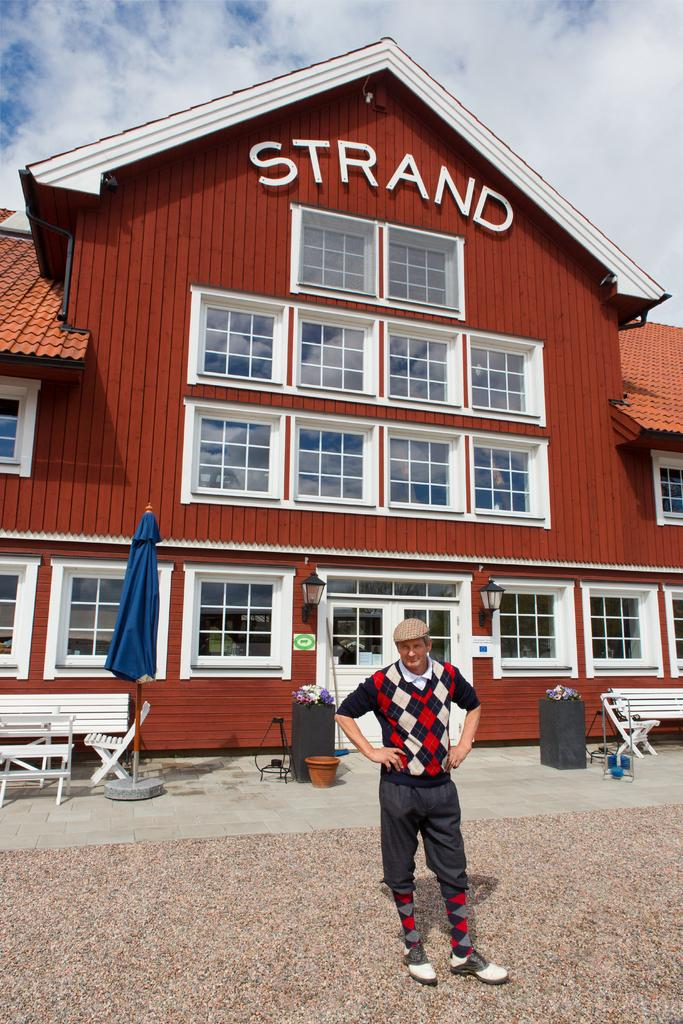What is the man in the image doing? The man is standing on a pavement. What objects can be seen in the background of the image? There are chairs, benches, tables, a house, and the sky visible in the background. How many girls are talking to the man in the image? There are no girls present in the image. What type of appliance is visible on the table in the image? There is no appliance visible on the table in the image. 